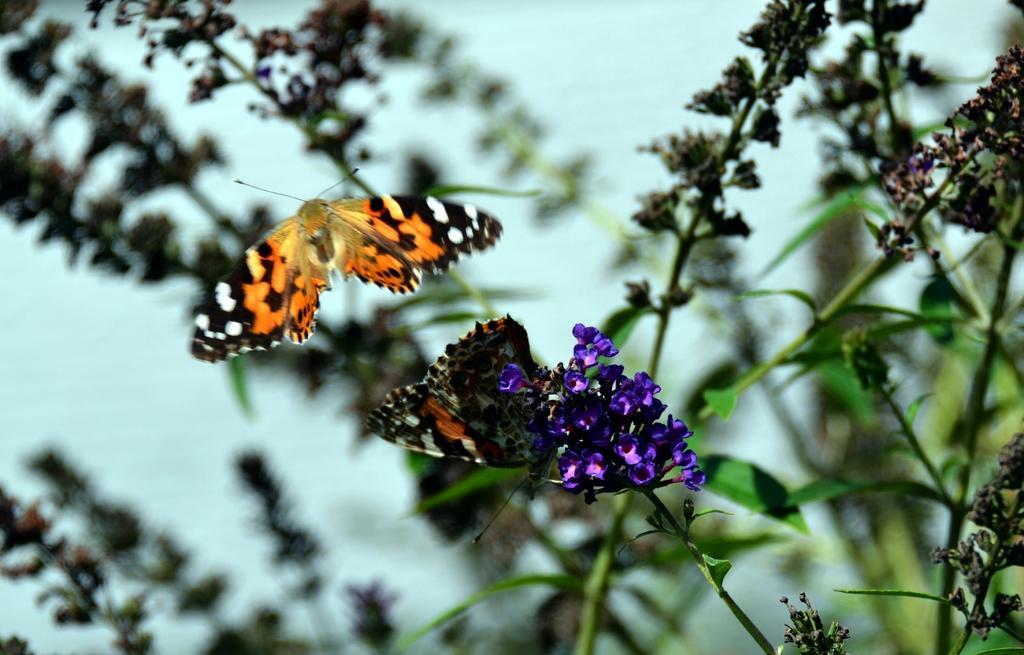Describe this image in one or two sentences. This picture consists of plant, on which I can see butterflies,flowers and leaves. 